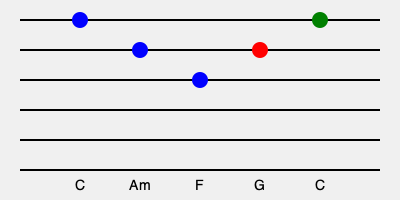Identify the chord progression represented on this guitar fretboard diagram and explain its significance in popular music, particularly in relation to songs by the Jonas Brothers. To identify the chord progression and understand its significance, let's follow these steps:

1. Chord Identification:
   - The blue dots represent the first three chords: C, Am, F
   - The red dot represents the fourth chord: G
   - The green dot represents the final chord: C

2. Progression Analysis:
   The chord progression shown is C - Am - F - G - C, which is commonly known as the I - vi - IV - V - I progression in the key of C major.

3. Roman Numeral Notation:
   In the key of C major:
   C (I) - Am (vi) - F (IV) - G (V) - C (I)

4. Significance in Popular Music:
   - This progression is widely used in pop, rock, and many other genres due to its pleasing sound and natural resolution.
   - It's often referred to as the "50s progression" or "doo-wop progression" because of its prevalence in 1950s pop music.
   - The progression creates a sense of movement and return, making it satisfying to listeners.

5. Jonas Brothers Connection:
   - The Jonas Brothers, known for their catchy pop-rock songs, often use variations of this progression.
   - For example, their hit song "Sucker" uses a similar progression (I - V - vi - IV) in the verses.
   - Understanding and utilizing such common progressions is crucial for aspiring musicians aiming to create popular, accessible music.

6. Musical Function:
   - I (C): Establishes the home key
   - vi (Am): Provides contrast and a minor feel
   - IV (F): Creates movement and tension
   - V (G): Builds maximum tension
   - I (C): Resolves back to the home key, providing closure

Understanding and being able to identify this progression is essential for any musician looking to analyze, compose, or perform popular music, especially in the style of successful pop-rock acts like the Jonas Brothers.
Answer: I - vi - IV - V - I progression (C - Am - F - G - C) 